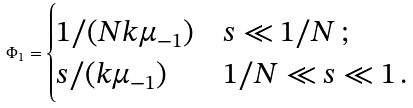Convert formula to latex. <formula><loc_0><loc_0><loc_500><loc_500>\Phi _ { 1 } = \begin{cases} 1 / ( N k \mu _ { - 1 } ) & s \ll 1 / N \, ; \\ s / ( k \mu _ { - 1 } ) & 1 / N \ll s \ll 1 \, . \end{cases}</formula> 